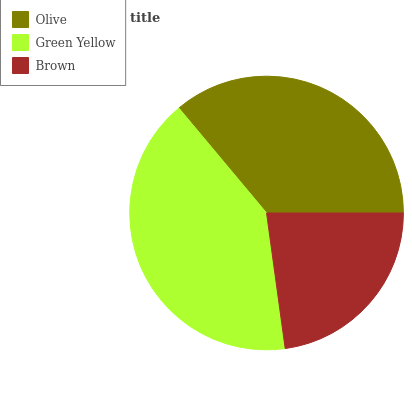Is Brown the minimum?
Answer yes or no. Yes. Is Green Yellow the maximum?
Answer yes or no. Yes. Is Green Yellow the minimum?
Answer yes or no. No. Is Brown the maximum?
Answer yes or no. No. Is Green Yellow greater than Brown?
Answer yes or no. Yes. Is Brown less than Green Yellow?
Answer yes or no. Yes. Is Brown greater than Green Yellow?
Answer yes or no. No. Is Green Yellow less than Brown?
Answer yes or no. No. Is Olive the high median?
Answer yes or no. Yes. Is Olive the low median?
Answer yes or no. Yes. Is Brown the high median?
Answer yes or no. No. Is Brown the low median?
Answer yes or no. No. 